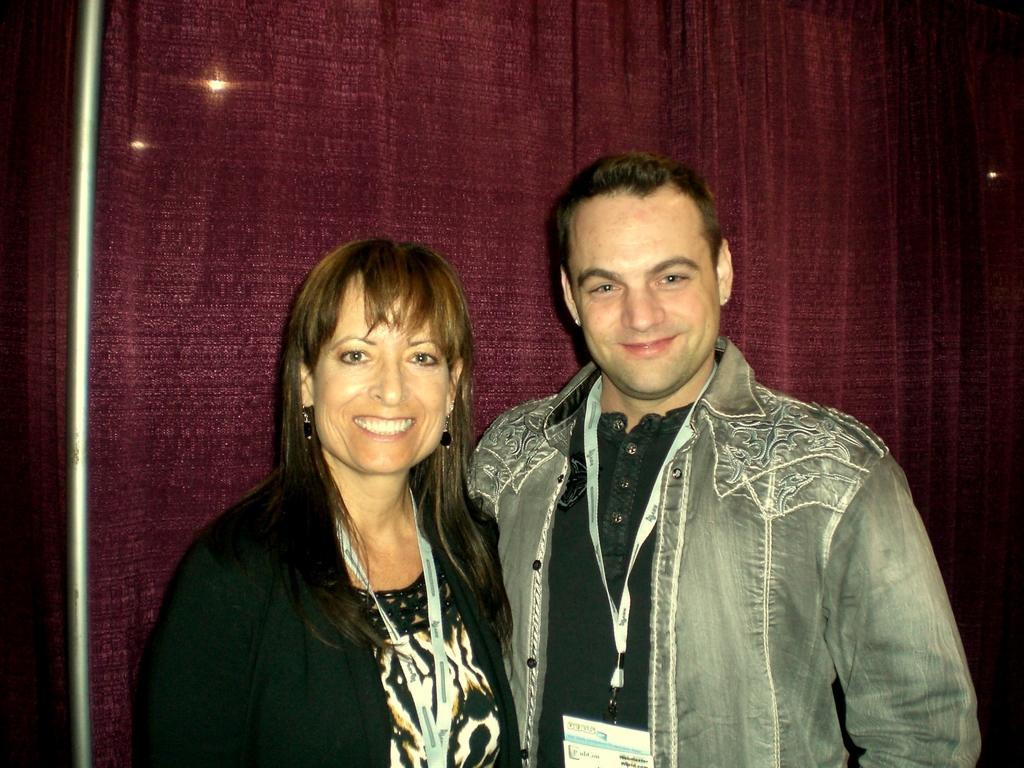How would you summarize this image in a sentence or two? In this image we can see a man and a woman wearing the identity cards and smiling. In the background we can see the curtain, lights and also a rod on the left. 